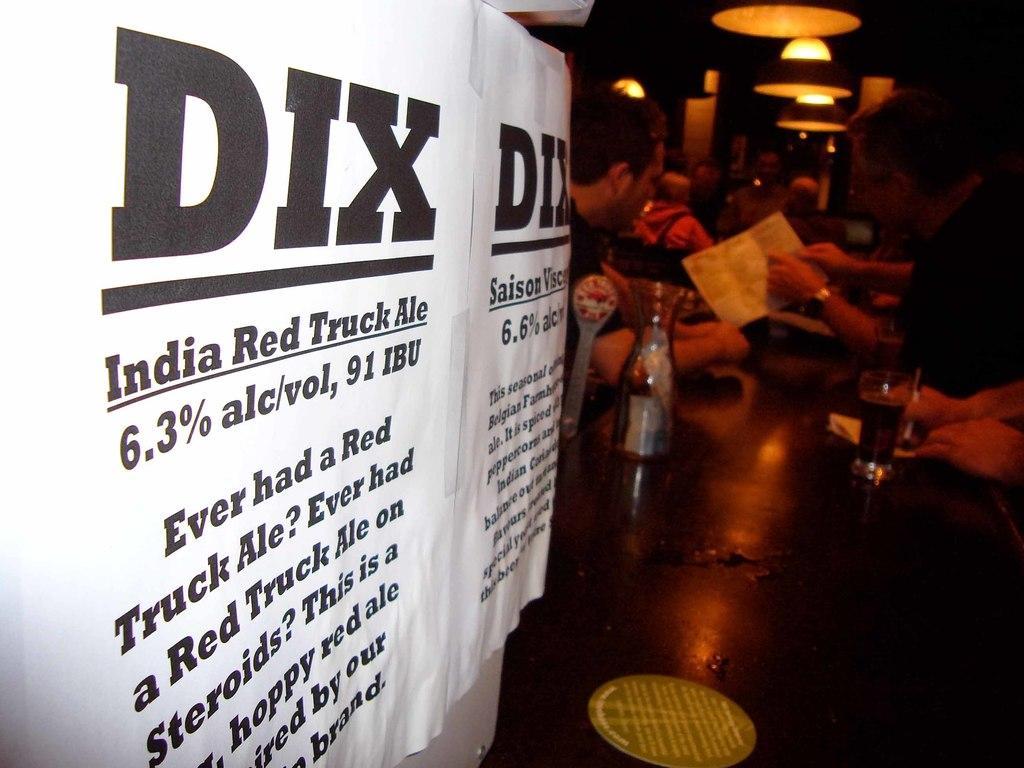Could you give a brief overview of what you see in this image? On the left there are posters. In the center of the picture there is a table, on the table there are bottle, glass and other objects. In the center of the background there are people sitting at the table. At the top there are lights. 